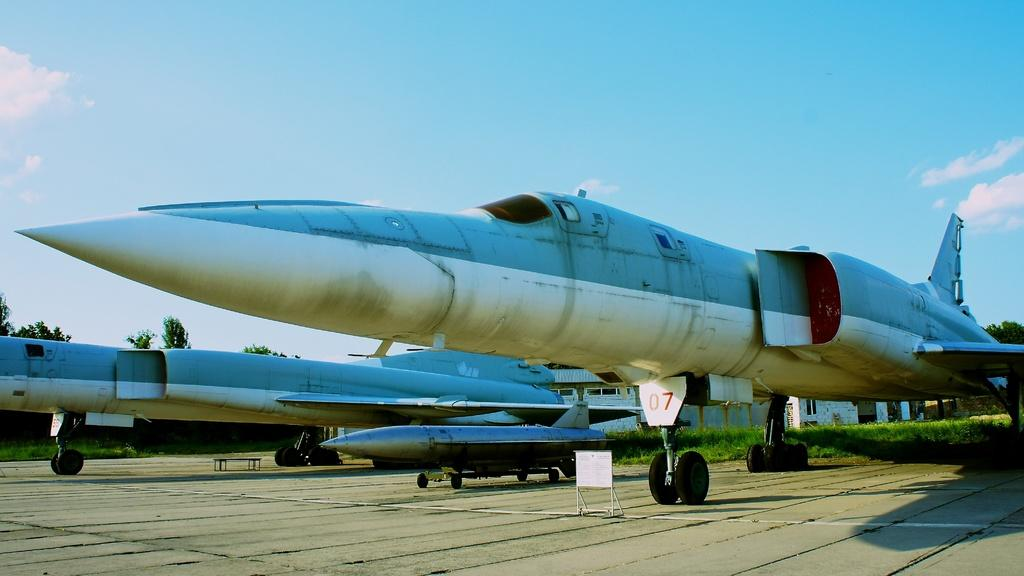<image>
Describe the image concisely. An airplane with 07 above the wheel of the plane. 